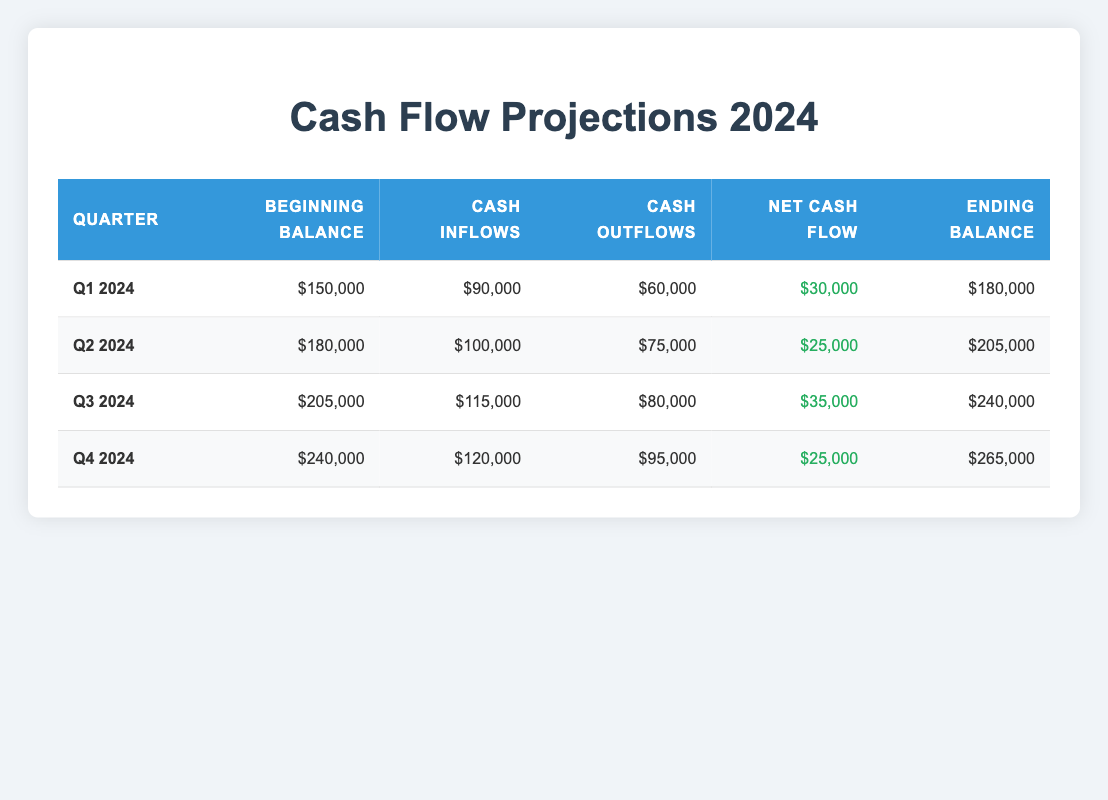What is the net cash flow for Q2 2024? The net cash flow can be found in the Q2 2024 row under the "Net Cash Flow" column. It shows a positive value of $25,000.
Answer: 25000 What is the total cash inflow for Q1 and Q3 2024 combined? The cash inflow for Q1 2024 is $90,000 and for Q3 2024 it is $115,000. Summing these inflows gives $90,000 + $115,000 = $205,000.
Answer: 205000 Is the ending cash balance for Q4 2024 greater than that of Q1 2024? The ending cash balance for Q4 2024 is $265,000, while for Q1 2024 it is $180,000. Since $265,000 is greater than $180,000, the statement is true.
Answer: Yes What is the average cash outflow across all four quarters? The cash outflows for each quarter are $60,000, $75,000, $80,000, and $95,000. To find the average, sum these values: $60,000 + $75,000 + $80,000 + $95,000 = $310,000, and divide by 4 (number of quarters), which gives $310,000 / 4 = $77,500.
Answer: 77500 In which quarter is the net cash flow the highest? Reviewing the net cash flow values: Q1 is $30,000, Q2 is $25,000, Q3 is $35,000, and Q4 is $25,000. The highest is in Q3 with $35,000.
Answer: Q3 2024 What is the difference between the beginning cash balance of Q4 2024 and Q2 2024? The beginning cash balance for Q4 2024 is $240,000 and for Q2 2024 it is $180,000. Subtracting the two gives $240,000 - $180,000 = $60,000.
Answer: 60000 Does Q3 2024 have more cash inflows than Q2 2024? Q3 2024 has cash inflows of $115,000 and Q2 2024 has $100,000. Since $115,000 is greater than $100,000, the statement is true.
Answer: Yes What is the ending cash balance for Q1 2024? The ending cash balance can be found in the Q1 2024 row under the "Ending Balance" column, which is $180,000.
Answer: 180000 What is the total net cash flow across all four quarters? The net cash flows are $30,000, $25,000, $35,000 and $25,000 for Q1, Q2, Q3, and Q4 respectively. Summing these gives $30,000 + $25,000 + $35,000 + $25,000 = $115,000.
Answer: 115000 